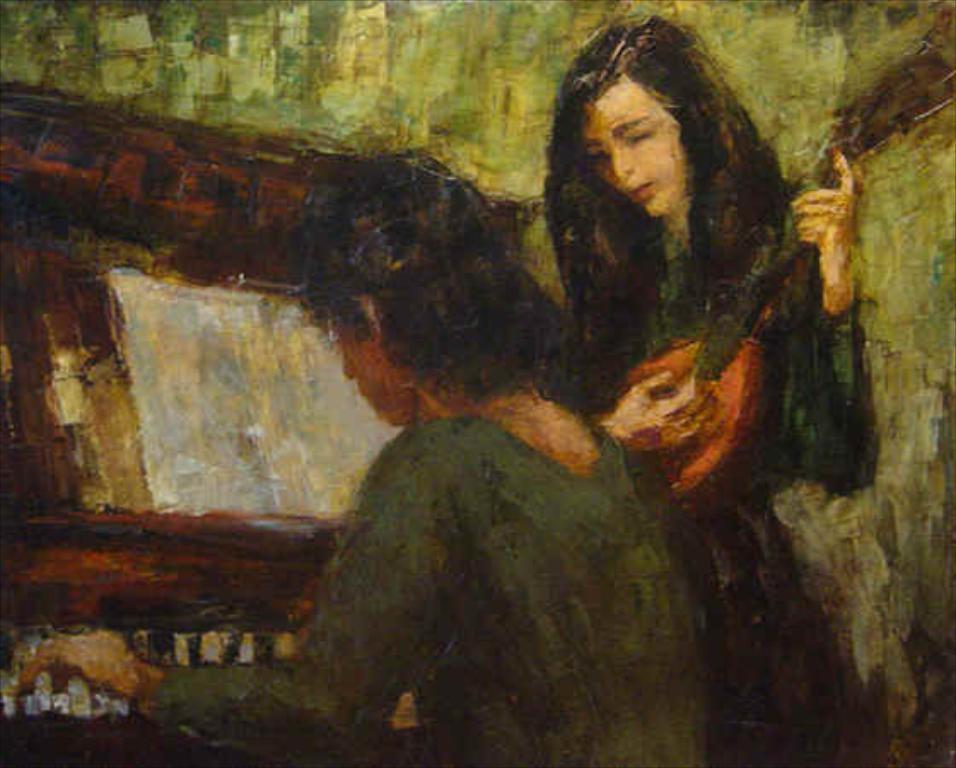Please provide a concise description of this image. In this picture I can see there are two women, one of them is playing the guitar and the other women is playing piano and in the backdrop there is a green color walls. 